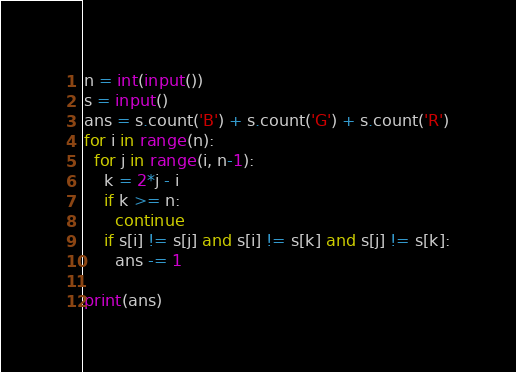<code> <loc_0><loc_0><loc_500><loc_500><_Python_>n = int(input())
s = input()
ans = s.count('B') + s.count('G') + s.count('R')
for i in range(n):
  for j in range(i, n-1):
    k = 2*j - i
    if k >= n:
      continue
    if s[i] != s[j] and s[i] != s[k] and s[j] != s[k]:
      ans -= 1

print(ans)</code> 